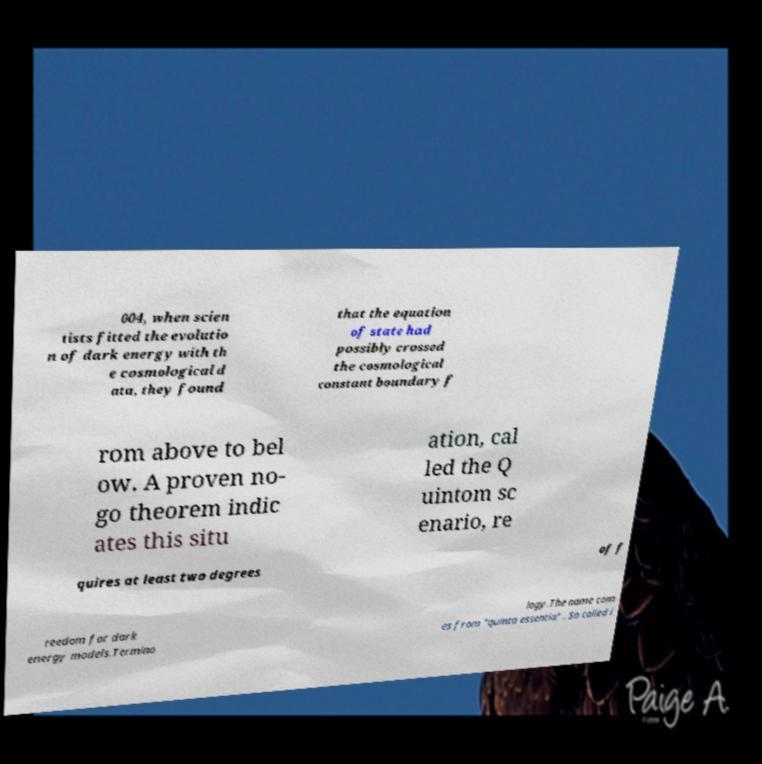Can you read and provide the text displayed in the image?This photo seems to have some interesting text. Can you extract and type it out for me? 004, when scien tists fitted the evolutio n of dark energy with th e cosmological d ata, they found that the equation of state had possibly crossed the cosmological constant boundary f rom above to bel ow. A proven no- go theorem indic ates this situ ation, cal led the Q uintom sc enario, re quires at least two degrees of f reedom for dark energy models.Termino logy.The name com es from "quinta essentia" . So called i 